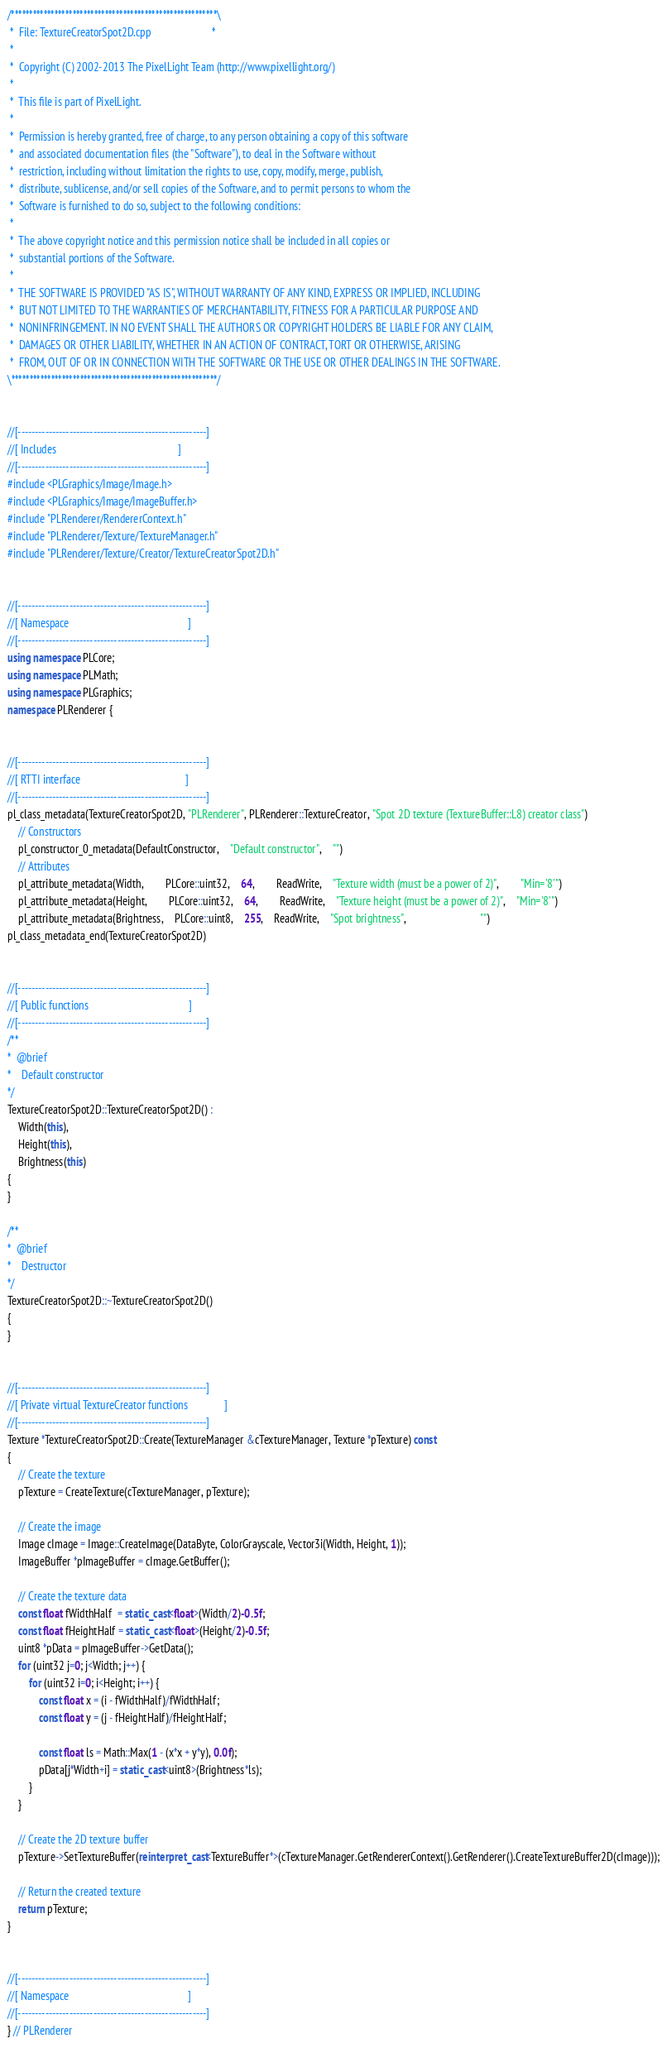<code> <loc_0><loc_0><loc_500><loc_500><_C++_>/*********************************************************\
 *  File: TextureCreatorSpot2D.cpp                       *
 *
 *  Copyright (C) 2002-2013 The PixelLight Team (http://www.pixellight.org/)
 *
 *  This file is part of PixelLight.
 *
 *  Permission is hereby granted, free of charge, to any person obtaining a copy of this software
 *  and associated documentation files (the "Software"), to deal in the Software without
 *  restriction, including without limitation the rights to use, copy, modify, merge, publish,
 *  distribute, sublicense, and/or sell copies of the Software, and to permit persons to whom the
 *  Software is furnished to do so, subject to the following conditions:
 *
 *  The above copyright notice and this permission notice shall be included in all copies or
 *  substantial portions of the Software.
 *
 *  THE SOFTWARE IS PROVIDED "AS IS", WITHOUT WARRANTY OF ANY KIND, EXPRESS OR IMPLIED, INCLUDING
 *  BUT NOT LIMITED TO THE WARRANTIES OF MERCHANTABILITY, FITNESS FOR A PARTICULAR PURPOSE AND
 *  NONINFRINGEMENT. IN NO EVENT SHALL THE AUTHORS OR COPYRIGHT HOLDERS BE LIABLE FOR ANY CLAIM,
 *  DAMAGES OR OTHER LIABILITY, WHETHER IN AN ACTION OF CONTRACT, TORT OR OTHERWISE, ARISING
 *  FROM, OUT OF OR IN CONNECTION WITH THE SOFTWARE OR THE USE OR OTHER DEALINGS IN THE SOFTWARE.
\*********************************************************/


//[-------------------------------------------------------]
//[ Includes                                              ]
//[-------------------------------------------------------]
#include <PLGraphics/Image/Image.h>
#include <PLGraphics/Image/ImageBuffer.h>
#include "PLRenderer/RendererContext.h"
#include "PLRenderer/Texture/TextureManager.h"
#include "PLRenderer/Texture/Creator/TextureCreatorSpot2D.h"


//[-------------------------------------------------------]
//[ Namespace                                             ]
//[-------------------------------------------------------]
using namespace PLCore;
using namespace PLMath;
using namespace PLGraphics;
namespace PLRenderer {


//[-------------------------------------------------------]
//[ RTTI interface                                        ]
//[-------------------------------------------------------]
pl_class_metadata(TextureCreatorSpot2D, "PLRenderer", PLRenderer::TextureCreator, "Spot 2D texture (TextureBuffer::L8) creator class")
	// Constructors
	pl_constructor_0_metadata(DefaultConstructor,	"Default constructor",	"")
	// Attributes
	pl_attribute_metadata(Width,		PLCore::uint32,	64,		ReadWrite,	"Texture width (must be a power of 2)",		"Min='8'")
	pl_attribute_metadata(Height,		PLCore::uint32,	64,		ReadWrite,	"Texture height (must be a power of 2)",	"Min='8'")
	pl_attribute_metadata(Brightness,	PLCore::uint8,	255,	ReadWrite,	"Spot brightness",							"")
pl_class_metadata_end(TextureCreatorSpot2D)


//[-------------------------------------------------------]
//[ Public functions                                      ]
//[-------------------------------------------------------]
/**
*  @brief
*    Default constructor
*/
TextureCreatorSpot2D::TextureCreatorSpot2D() :
	Width(this),
	Height(this),
	Brightness(this)
{
}

/**
*  @brief
*    Destructor
*/
TextureCreatorSpot2D::~TextureCreatorSpot2D()
{
}


//[-------------------------------------------------------]
//[ Private virtual TextureCreator functions              ]
//[-------------------------------------------------------]
Texture *TextureCreatorSpot2D::Create(TextureManager &cTextureManager, Texture *pTexture) const
{
	// Create the texture
	pTexture = CreateTexture(cTextureManager, pTexture);

	// Create the image
	Image cImage = Image::CreateImage(DataByte, ColorGrayscale, Vector3i(Width, Height, 1));
	ImageBuffer *pImageBuffer = cImage.GetBuffer();

	// Create the texture data
	const float fWidthHalf  = static_cast<float>(Width/2)-0.5f;
	const float fHeightHalf = static_cast<float>(Height/2)-0.5f;
	uint8 *pData = pImageBuffer->GetData();
	for (uint32 j=0; j<Width; j++) {
		for (uint32 i=0; i<Height; i++) {
			const float x = (i - fWidthHalf)/fWidthHalf;
			const float y = (j - fHeightHalf)/fHeightHalf;

			const float ls = Math::Max(1 - (x*x + y*y), 0.0f);
			pData[j*Width+i] = static_cast<uint8>(Brightness*ls);
		}
	}

	// Create the 2D texture buffer
	pTexture->SetTextureBuffer(reinterpret_cast<TextureBuffer*>(cTextureManager.GetRendererContext().GetRenderer().CreateTextureBuffer2D(cImage)));

	// Return the created texture
	return pTexture;
}


//[-------------------------------------------------------]
//[ Namespace                                             ]
//[-------------------------------------------------------]
} // PLRenderer
</code> 